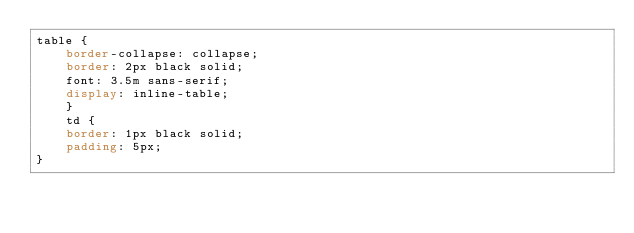<code> <loc_0><loc_0><loc_500><loc_500><_CSS_>table {
    border-collapse: collapse;
    border: 2px black solid;
    font: 3.5m sans-serif;
    display: inline-table;
    }
    td {
    border: 1px black solid;
    padding: 5px;
}</code> 